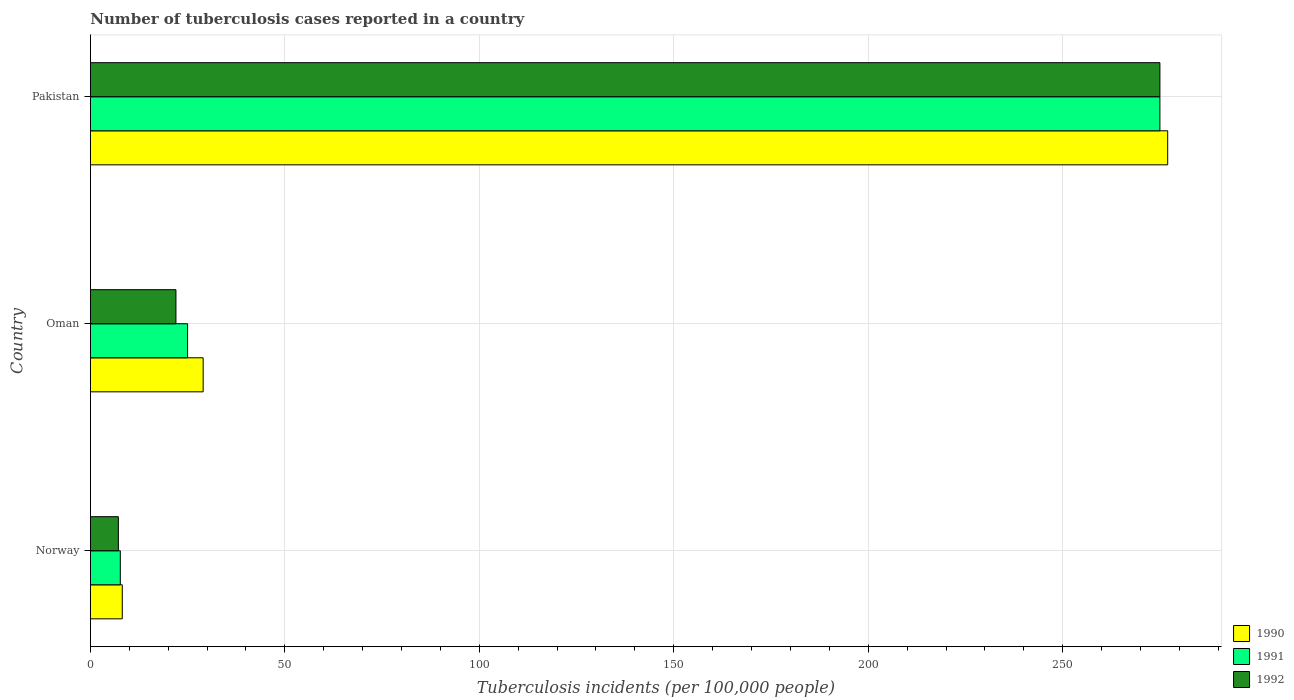How many groups of bars are there?
Provide a succinct answer. 3. Are the number of bars per tick equal to the number of legend labels?
Your answer should be very brief. Yes. In how many cases, is the number of bars for a given country not equal to the number of legend labels?
Your answer should be compact. 0. What is the number of tuberculosis cases reported in in 1992 in Norway?
Provide a succinct answer. 7.2. Across all countries, what is the maximum number of tuberculosis cases reported in in 1991?
Keep it short and to the point. 275. Across all countries, what is the minimum number of tuberculosis cases reported in in 1990?
Provide a short and direct response. 8.2. What is the total number of tuberculosis cases reported in in 1990 in the graph?
Ensure brevity in your answer.  314.2. What is the difference between the number of tuberculosis cases reported in in 1992 in Norway and that in Oman?
Make the answer very short. -14.8. What is the difference between the number of tuberculosis cases reported in in 1990 in Pakistan and the number of tuberculosis cases reported in in 1992 in Norway?
Keep it short and to the point. 269.8. What is the average number of tuberculosis cases reported in in 1991 per country?
Provide a succinct answer. 102.57. What is the difference between the number of tuberculosis cases reported in in 1991 and number of tuberculosis cases reported in in 1990 in Norway?
Provide a succinct answer. -0.5. In how many countries, is the number of tuberculosis cases reported in in 1992 greater than 50 ?
Offer a very short reply. 1. What is the ratio of the number of tuberculosis cases reported in in 1990 in Oman to that in Pakistan?
Your answer should be very brief. 0.1. Is the number of tuberculosis cases reported in in 1990 in Norway less than that in Oman?
Make the answer very short. Yes. Is the difference between the number of tuberculosis cases reported in in 1991 in Norway and Oman greater than the difference between the number of tuberculosis cases reported in in 1990 in Norway and Oman?
Offer a very short reply. Yes. What is the difference between the highest and the second highest number of tuberculosis cases reported in in 1990?
Provide a short and direct response. 248. What is the difference between the highest and the lowest number of tuberculosis cases reported in in 1990?
Keep it short and to the point. 268.8. In how many countries, is the number of tuberculosis cases reported in in 1991 greater than the average number of tuberculosis cases reported in in 1991 taken over all countries?
Your response must be concise. 1. What does the 3rd bar from the bottom in Oman represents?
Your response must be concise. 1992. Is it the case that in every country, the sum of the number of tuberculosis cases reported in in 1990 and number of tuberculosis cases reported in in 1992 is greater than the number of tuberculosis cases reported in in 1991?
Offer a terse response. Yes. Are all the bars in the graph horizontal?
Ensure brevity in your answer.  Yes. What is the difference between two consecutive major ticks on the X-axis?
Offer a terse response. 50. Does the graph contain any zero values?
Provide a succinct answer. No. Does the graph contain grids?
Offer a very short reply. Yes. Where does the legend appear in the graph?
Provide a short and direct response. Bottom right. How many legend labels are there?
Give a very brief answer. 3. What is the title of the graph?
Provide a succinct answer. Number of tuberculosis cases reported in a country. Does "1999" appear as one of the legend labels in the graph?
Your answer should be compact. No. What is the label or title of the X-axis?
Keep it short and to the point. Tuberculosis incidents (per 100,0 people). What is the Tuberculosis incidents (per 100,000 people) of 1990 in Norway?
Give a very brief answer. 8.2. What is the Tuberculosis incidents (per 100,000 people) of 1990 in Oman?
Provide a short and direct response. 29. What is the Tuberculosis incidents (per 100,000 people) of 1991 in Oman?
Your answer should be compact. 25. What is the Tuberculosis incidents (per 100,000 people) in 1992 in Oman?
Offer a terse response. 22. What is the Tuberculosis incidents (per 100,000 people) in 1990 in Pakistan?
Give a very brief answer. 277. What is the Tuberculosis incidents (per 100,000 people) in 1991 in Pakistan?
Provide a short and direct response. 275. What is the Tuberculosis incidents (per 100,000 people) of 1992 in Pakistan?
Your answer should be compact. 275. Across all countries, what is the maximum Tuberculosis incidents (per 100,000 people) of 1990?
Your answer should be compact. 277. Across all countries, what is the maximum Tuberculosis incidents (per 100,000 people) of 1991?
Provide a succinct answer. 275. Across all countries, what is the maximum Tuberculosis incidents (per 100,000 people) of 1992?
Offer a terse response. 275. Across all countries, what is the minimum Tuberculosis incidents (per 100,000 people) in 1992?
Offer a very short reply. 7.2. What is the total Tuberculosis incidents (per 100,000 people) in 1990 in the graph?
Keep it short and to the point. 314.2. What is the total Tuberculosis incidents (per 100,000 people) of 1991 in the graph?
Give a very brief answer. 307.7. What is the total Tuberculosis incidents (per 100,000 people) of 1992 in the graph?
Offer a very short reply. 304.2. What is the difference between the Tuberculosis incidents (per 100,000 people) in 1990 in Norway and that in Oman?
Make the answer very short. -20.8. What is the difference between the Tuberculosis incidents (per 100,000 people) of 1991 in Norway and that in Oman?
Your response must be concise. -17.3. What is the difference between the Tuberculosis incidents (per 100,000 people) of 1992 in Norway and that in Oman?
Your answer should be very brief. -14.8. What is the difference between the Tuberculosis incidents (per 100,000 people) of 1990 in Norway and that in Pakistan?
Keep it short and to the point. -268.8. What is the difference between the Tuberculosis incidents (per 100,000 people) in 1991 in Norway and that in Pakistan?
Your response must be concise. -267.3. What is the difference between the Tuberculosis incidents (per 100,000 people) in 1992 in Norway and that in Pakistan?
Provide a short and direct response. -267.8. What is the difference between the Tuberculosis incidents (per 100,000 people) of 1990 in Oman and that in Pakistan?
Your answer should be very brief. -248. What is the difference between the Tuberculosis incidents (per 100,000 people) of 1991 in Oman and that in Pakistan?
Offer a very short reply. -250. What is the difference between the Tuberculosis incidents (per 100,000 people) in 1992 in Oman and that in Pakistan?
Offer a terse response. -253. What is the difference between the Tuberculosis incidents (per 100,000 people) in 1990 in Norway and the Tuberculosis incidents (per 100,000 people) in 1991 in Oman?
Provide a succinct answer. -16.8. What is the difference between the Tuberculosis incidents (per 100,000 people) of 1990 in Norway and the Tuberculosis incidents (per 100,000 people) of 1992 in Oman?
Provide a succinct answer. -13.8. What is the difference between the Tuberculosis incidents (per 100,000 people) in 1991 in Norway and the Tuberculosis incidents (per 100,000 people) in 1992 in Oman?
Your answer should be compact. -14.3. What is the difference between the Tuberculosis incidents (per 100,000 people) in 1990 in Norway and the Tuberculosis incidents (per 100,000 people) in 1991 in Pakistan?
Offer a very short reply. -266.8. What is the difference between the Tuberculosis incidents (per 100,000 people) of 1990 in Norway and the Tuberculosis incidents (per 100,000 people) of 1992 in Pakistan?
Provide a succinct answer. -266.8. What is the difference between the Tuberculosis incidents (per 100,000 people) of 1991 in Norway and the Tuberculosis incidents (per 100,000 people) of 1992 in Pakistan?
Your answer should be compact. -267.3. What is the difference between the Tuberculosis incidents (per 100,000 people) in 1990 in Oman and the Tuberculosis incidents (per 100,000 people) in 1991 in Pakistan?
Offer a very short reply. -246. What is the difference between the Tuberculosis incidents (per 100,000 people) in 1990 in Oman and the Tuberculosis incidents (per 100,000 people) in 1992 in Pakistan?
Provide a short and direct response. -246. What is the difference between the Tuberculosis incidents (per 100,000 people) in 1991 in Oman and the Tuberculosis incidents (per 100,000 people) in 1992 in Pakistan?
Give a very brief answer. -250. What is the average Tuberculosis incidents (per 100,000 people) of 1990 per country?
Your answer should be very brief. 104.73. What is the average Tuberculosis incidents (per 100,000 people) of 1991 per country?
Your response must be concise. 102.57. What is the average Tuberculosis incidents (per 100,000 people) of 1992 per country?
Offer a terse response. 101.4. What is the difference between the Tuberculosis incidents (per 100,000 people) in 1990 and Tuberculosis incidents (per 100,000 people) in 1991 in Norway?
Provide a short and direct response. 0.5. What is the difference between the Tuberculosis incidents (per 100,000 people) in 1991 and Tuberculosis incidents (per 100,000 people) in 1992 in Norway?
Your answer should be very brief. 0.5. What is the difference between the Tuberculosis incidents (per 100,000 people) in 1990 and Tuberculosis incidents (per 100,000 people) in 1992 in Oman?
Give a very brief answer. 7. What is the difference between the Tuberculosis incidents (per 100,000 people) in 1991 and Tuberculosis incidents (per 100,000 people) in 1992 in Oman?
Give a very brief answer. 3. What is the difference between the Tuberculosis incidents (per 100,000 people) of 1990 and Tuberculosis incidents (per 100,000 people) of 1991 in Pakistan?
Your response must be concise. 2. What is the ratio of the Tuberculosis incidents (per 100,000 people) of 1990 in Norway to that in Oman?
Offer a very short reply. 0.28. What is the ratio of the Tuberculosis incidents (per 100,000 people) in 1991 in Norway to that in Oman?
Your answer should be very brief. 0.31. What is the ratio of the Tuberculosis incidents (per 100,000 people) in 1992 in Norway to that in Oman?
Ensure brevity in your answer.  0.33. What is the ratio of the Tuberculosis incidents (per 100,000 people) in 1990 in Norway to that in Pakistan?
Provide a succinct answer. 0.03. What is the ratio of the Tuberculosis incidents (per 100,000 people) in 1991 in Norway to that in Pakistan?
Your response must be concise. 0.03. What is the ratio of the Tuberculosis incidents (per 100,000 people) of 1992 in Norway to that in Pakistan?
Make the answer very short. 0.03. What is the ratio of the Tuberculosis incidents (per 100,000 people) of 1990 in Oman to that in Pakistan?
Provide a short and direct response. 0.1. What is the ratio of the Tuberculosis incidents (per 100,000 people) of 1991 in Oman to that in Pakistan?
Give a very brief answer. 0.09. What is the ratio of the Tuberculosis incidents (per 100,000 people) of 1992 in Oman to that in Pakistan?
Give a very brief answer. 0.08. What is the difference between the highest and the second highest Tuberculosis incidents (per 100,000 people) of 1990?
Make the answer very short. 248. What is the difference between the highest and the second highest Tuberculosis incidents (per 100,000 people) of 1991?
Provide a succinct answer. 250. What is the difference between the highest and the second highest Tuberculosis incidents (per 100,000 people) in 1992?
Your answer should be very brief. 253. What is the difference between the highest and the lowest Tuberculosis incidents (per 100,000 people) of 1990?
Your answer should be compact. 268.8. What is the difference between the highest and the lowest Tuberculosis incidents (per 100,000 people) of 1991?
Your answer should be very brief. 267.3. What is the difference between the highest and the lowest Tuberculosis incidents (per 100,000 people) in 1992?
Offer a very short reply. 267.8. 